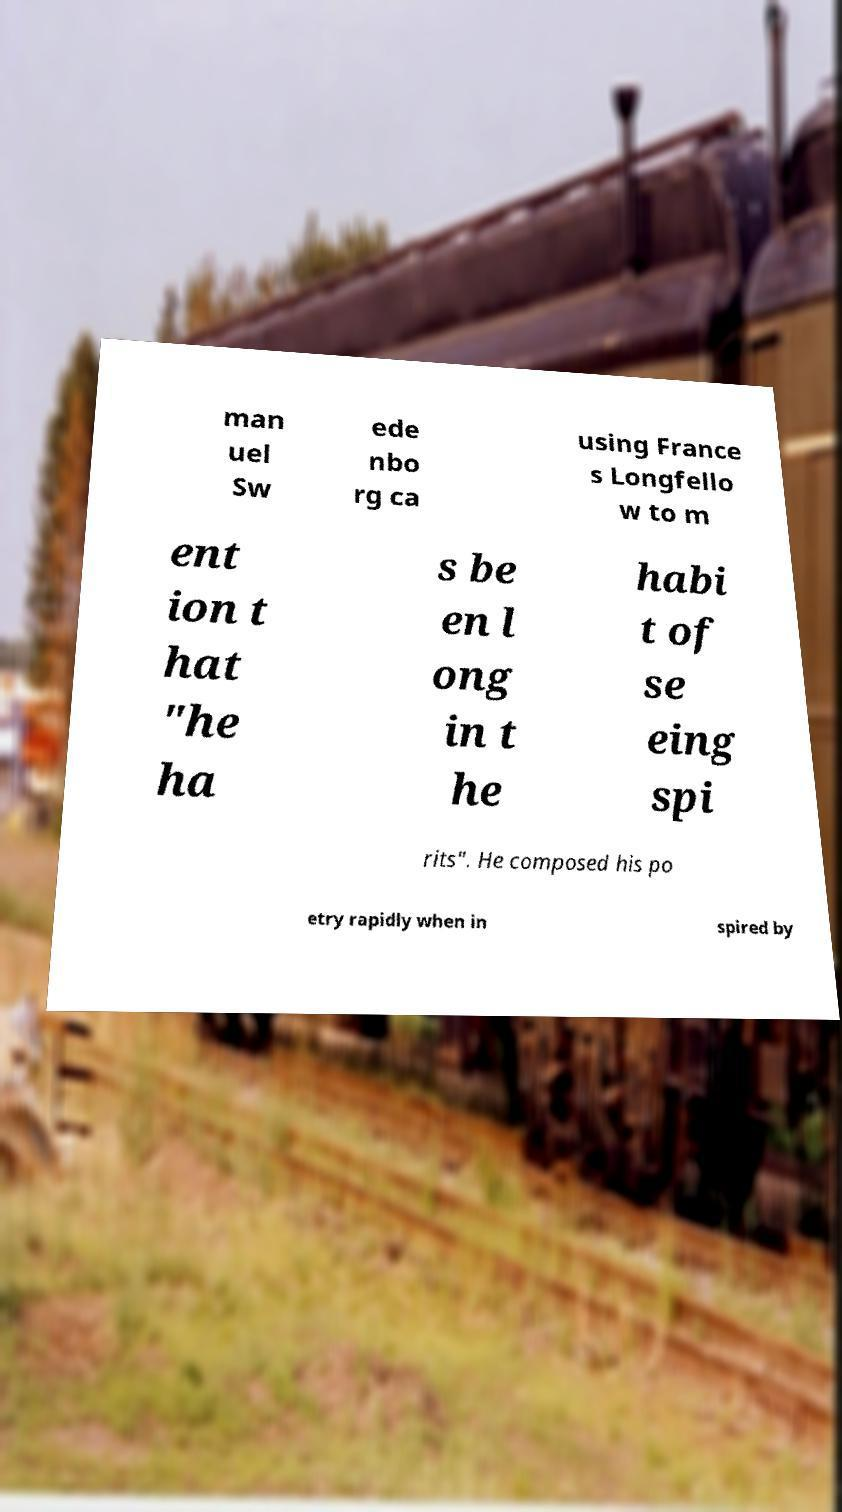What messages or text are displayed in this image? I need them in a readable, typed format. man uel Sw ede nbo rg ca using France s Longfello w to m ent ion t hat "he ha s be en l ong in t he habi t of se eing spi rits". He composed his po etry rapidly when in spired by 